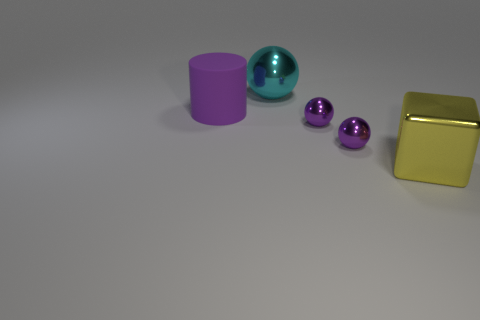Is there any other thing that has the same material as the big purple cylinder?
Make the answer very short. No. Is there a small shiny thing of the same color as the big rubber cylinder?
Provide a short and direct response. Yes. There is a large thing that is both in front of the big metal sphere and behind the yellow metal cube; what shape is it?
Provide a succinct answer. Cylinder. Is there a yellow block that has the same material as the cyan thing?
Keep it short and to the point. Yes. Is the number of large cylinders that are behind the purple rubber cylinder the same as the number of yellow metal objects that are in front of the large cyan thing?
Your answer should be very brief. No. What size is the thing that is on the left side of the big cyan metallic thing?
Offer a very short reply. Large. The purple thing on the left side of the big metal thing that is behind the yellow metal object is made of what material?
Offer a terse response. Rubber. There is a big matte cylinder in front of the big shiny thing behind the yellow metal object; what number of purple spheres are on the right side of it?
Your response must be concise. 2. Do the ball that is behind the big purple thing and the thing on the left side of the big metal ball have the same material?
Offer a terse response. No. How many other objects are the same shape as the large cyan metallic object?
Keep it short and to the point. 2. 